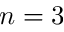<formula> <loc_0><loc_0><loc_500><loc_500>n = 3</formula> 